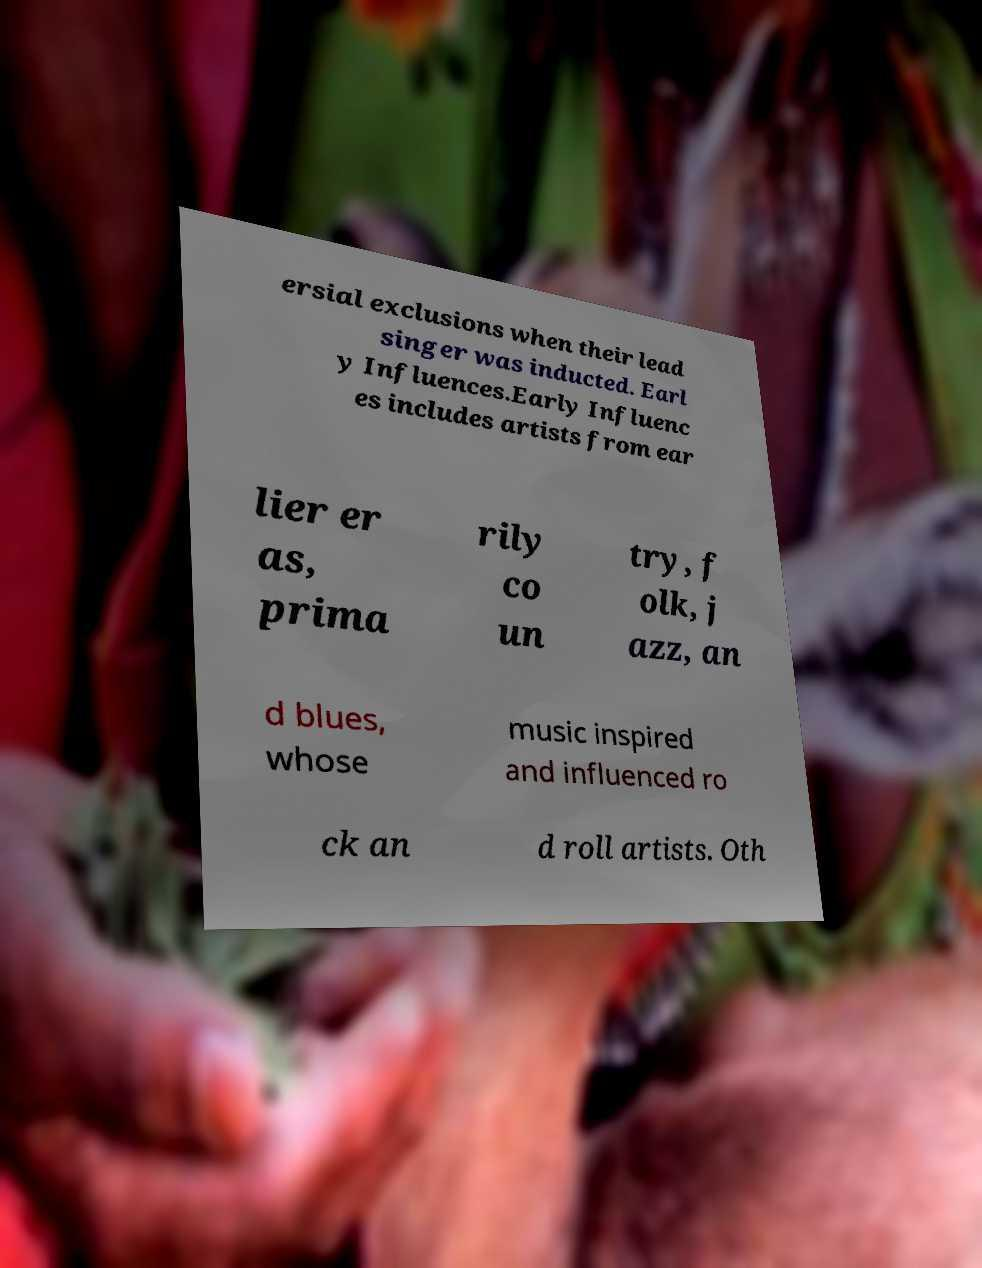Can you read and provide the text displayed in the image?This photo seems to have some interesting text. Can you extract and type it out for me? ersial exclusions when their lead singer was inducted. Earl y Influences.Early Influenc es includes artists from ear lier er as, prima rily co un try, f olk, j azz, an d blues, whose music inspired and influenced ro ck an d roll artists. Oth 